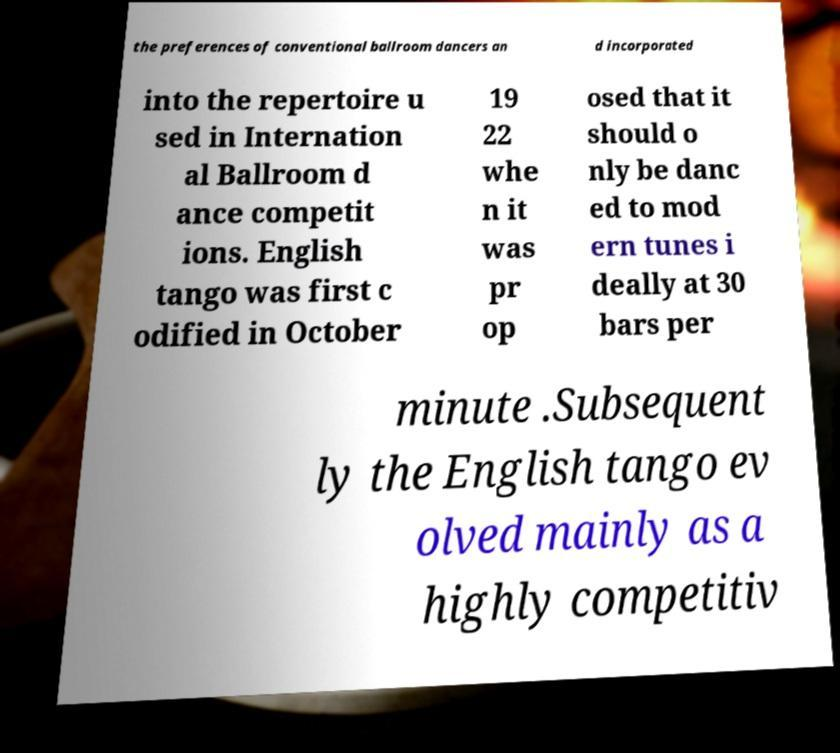Can you read and provide the text displayed in the image?This photo seems to have some interesting text. Can you extract and type it out for me? the preferences of conventional ballroom dancers an d incorporated into the repertoire u sed in Internation al Ballroom d ance competit ions. English tango was first c odified in October 19 22 whe n it was pr op osed that it should o nly be danc ed to mod ern tunes i deally at 30 bars per minute .Subsequent ly the English tango ev olved mainly as a highly competitiv 